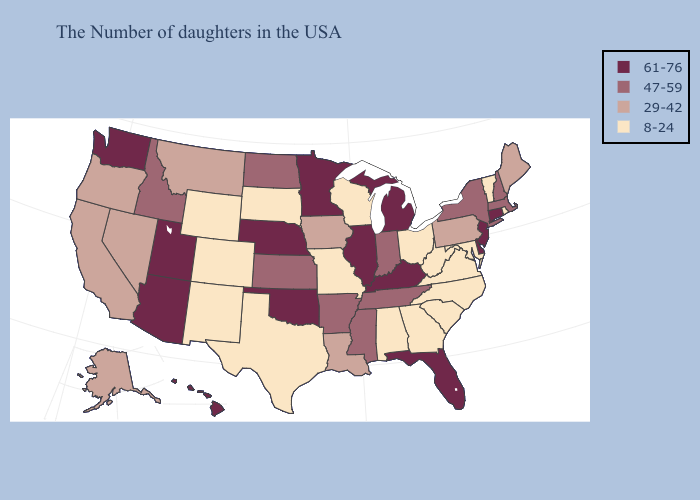Name the states that have a value in the range 47-59?
Concise answer only. Massachusetts, New Hampshire, New York, Indiana, Tennessee, Mississippi, Arkansas, Kansas, North Dakota, Idaho. What is the lowest value in states that border Indiana?
Answer briefly. 8-24. Among the states that border Kansas , which have the lowest value?
Concise answer only. Missouri, Colorado. Among the states that border Texas , which have the highest value?
Be succinct. Oklahoma. Is the legend a continuous bar?
Quick response, please. No. What is the highest value in the West ?
Short answer required. 61-76. What is the highest value in states that border Texas?
Concise answer only. 61-76. Among the states that border California , which have the highest value?
Quick response, please. Arizona. Name the states that have a value in the range 61-76?
Answer briefly. Connecticut, New Jersey, Delaware, Florida, Michigan, Kentucky, Illinois, Minnesota, Nebraska, Oklahoma, Utah, Arizona, Washington, Hawaii. What is the highest value in the MidWest ?
Be succinct. 61-76. What is the value of Indiana?
Give a very brief answer. 47-59. Name the states that have a value in the range 61-76?
Answer briefly. Connecticut, New Jersey, Delaware, Florida, Michigan, Kentucky, Illinois, Minnesota, Nebraska, Oklahoma, Utah, Arizona, Washington, Hawaii. What is the value of Texas?
Short answer required. 8-24. What is the highest value in the West ?
Give a very brief answer. 61-76. 